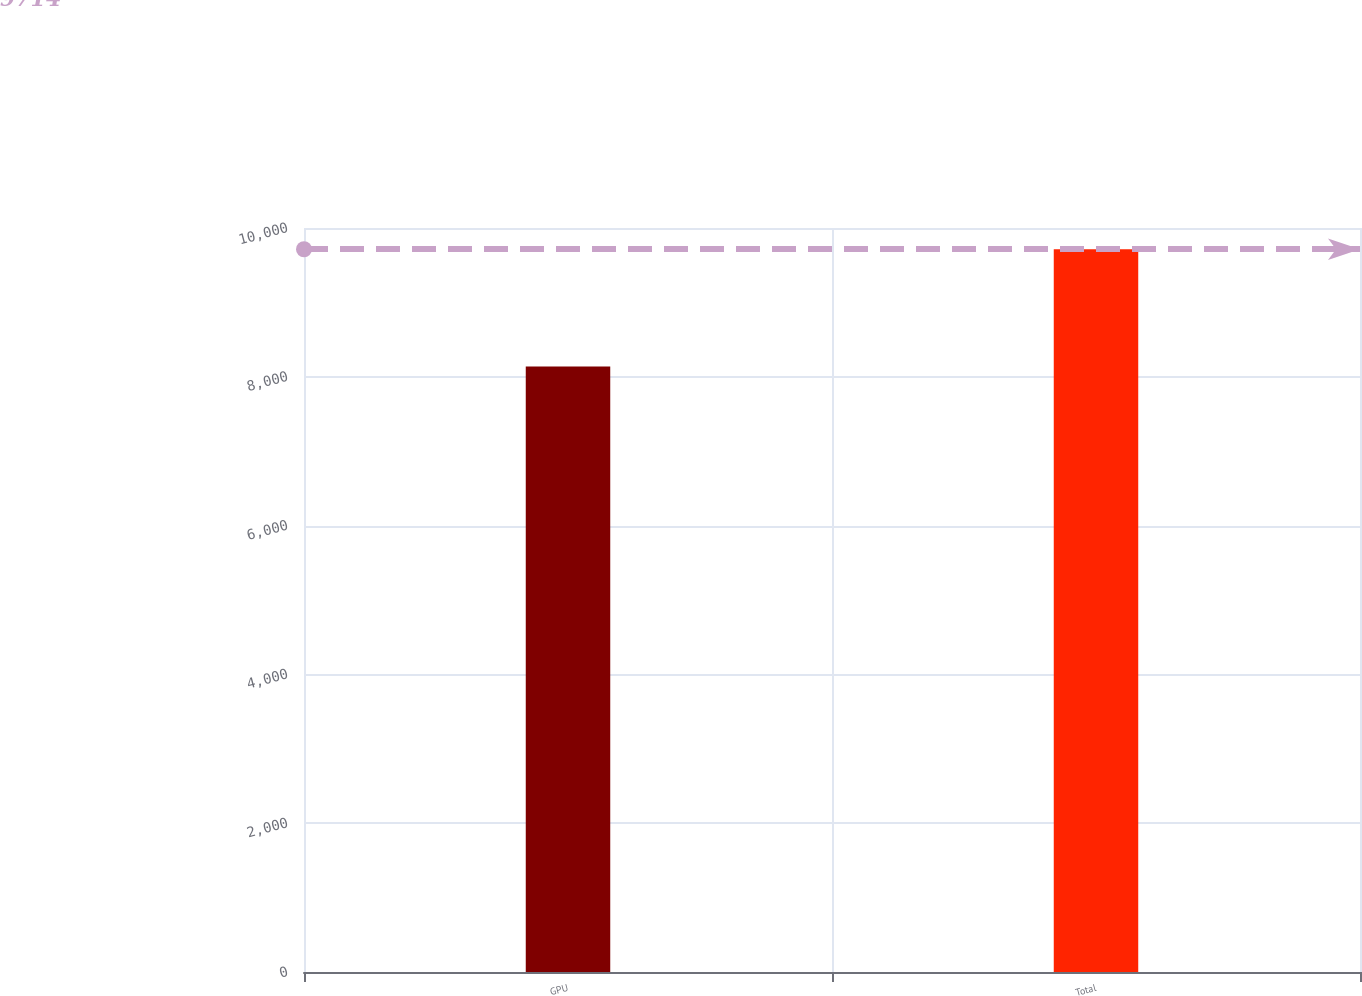<chart> <loc_0><loc_0><loc_500><loc_500><bar_chart><fcel>GPU<fcel>Total<nl><fcel>8137<fcel>9714<nl></chart> 